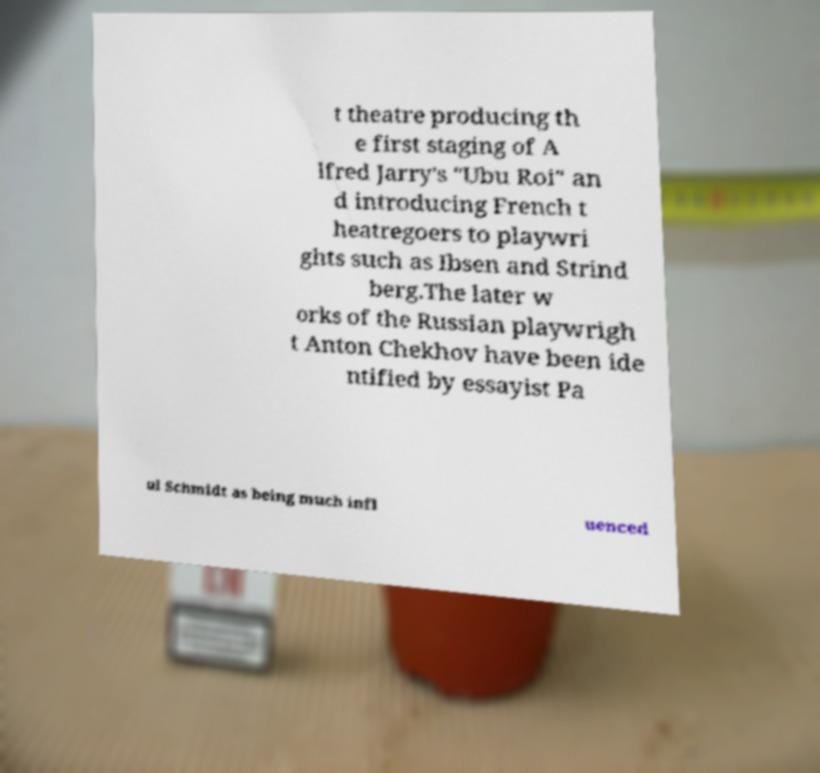Can you accurately transcribe the text from the provided image for me? t theatre producing th e first staging of A lfred Jarry's "Ubu Roi" an d introducing French t heatregoers to playwri ghts such as Ibsen and Strind berg.The later w orks of the Russian playwrigh t Anton Chekhov have been ide ntified by essayist Pa ul Schmidt as being much infl uenced 